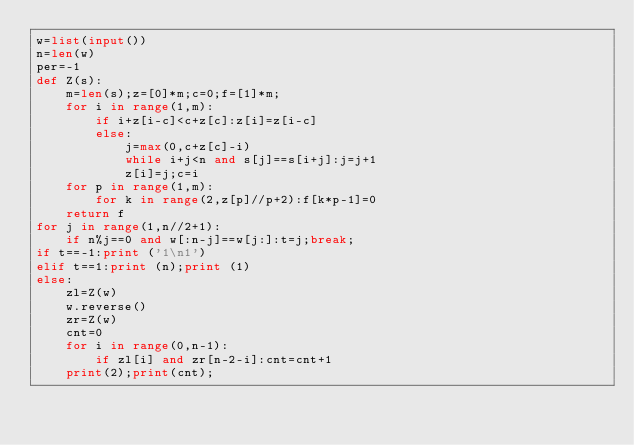Convert code to text. <code><loc_0><loc_0><loc_500><loc_500><_Python_>w=list(input())
n=len(w)
per=-1
def Z(s):
    m=len(s);z=[0]*m;c=0;f=[1]*m;
    for i in range(1,m):
        if i+z[i-c]<c+z[c]:z[i]=z[i-c]
        else:
            j=max(0,c+z[c]-i)
            while i+j<n and s[j]==s[i+j]:j=j+1
            z[i]=j;c=i
    for p in range(1,m):
        for k in range(2,z[p]//p+2):f[k*p-1]=0
    return f
for j in range(1,n//2+1):
    if n%j==0 and w[:n-j]==w[j:]:t=j;break;
if t==-1:print ('1\n1')
elif t==1:print (n);print (1)
else:
    zl=Z(w)
    w.reverse()
    zr=Z(w)
    cnt=0
    for i in range(0,n-1):
        if zl[i] and zr[n-2-i]:cnt=cnt+1
    print(2);print(cnt);</code> 